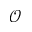<formula> <loc_0><loc_0><loc_500><loc_500>\mathcal { O }</formula> 